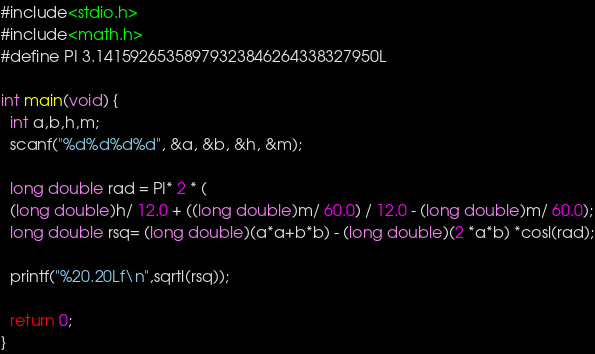<code> <loc_0><loc_0><loc_500><loc_500><_C_>#include<stdio.h>
#include<math.h>
#define PI 3.14159265358979323846264338327950L

int main(void) {
  int a,b,h,m;
  scanf("%d%d%d%d", &a, &b, &h, &m);
  
  long double rad = PI* 2 * (
  (long double)h/ 12.0 + ((long double)m/ 60.0) / 12.0 - (long double)m/ 60.0);
  long double rsq= (long double)(a*a+b*b) - (long double)(2 *a*b) *cosl(rad);
  
  printf("%20.20Lf\n",sqrtl(rsq));
  
  return 0;
}</code> 